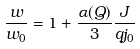<formula> <loc_0><loc_0><loc_500><loc_500>\frac { w } { w _ { 0 } } = 1 + \frac { \alpha ( Q ) } { 3 } \frac { J } { q j _ { 0 } }</formula> 